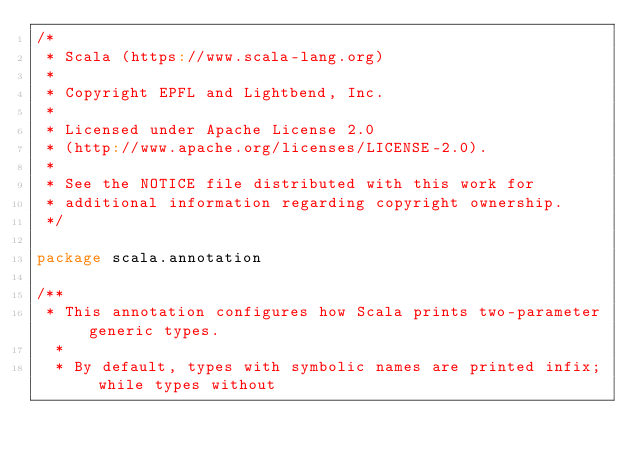Convert code to text. <code><loc_0><loc_0><loc_500><loc_500><_Scala_>/*
 * Scala (https://www.scala-lang.org)
 *
 * Copyright EPFL and Lightbend, Inc.
 *
 * Licensed under Apache License 2.0
 * (http://www.apache.org/licenses/LICENSE-2.0).
 *
 * See the NOTICE file distributed with this work for
 * additional information regarding copyright ownership.
 */

package scala.annotation

/**
 * This annotation configures how Scala prints two-parameter generic types.
  *
  * By default, types with symbolic names are printed infix; while types without</code> 